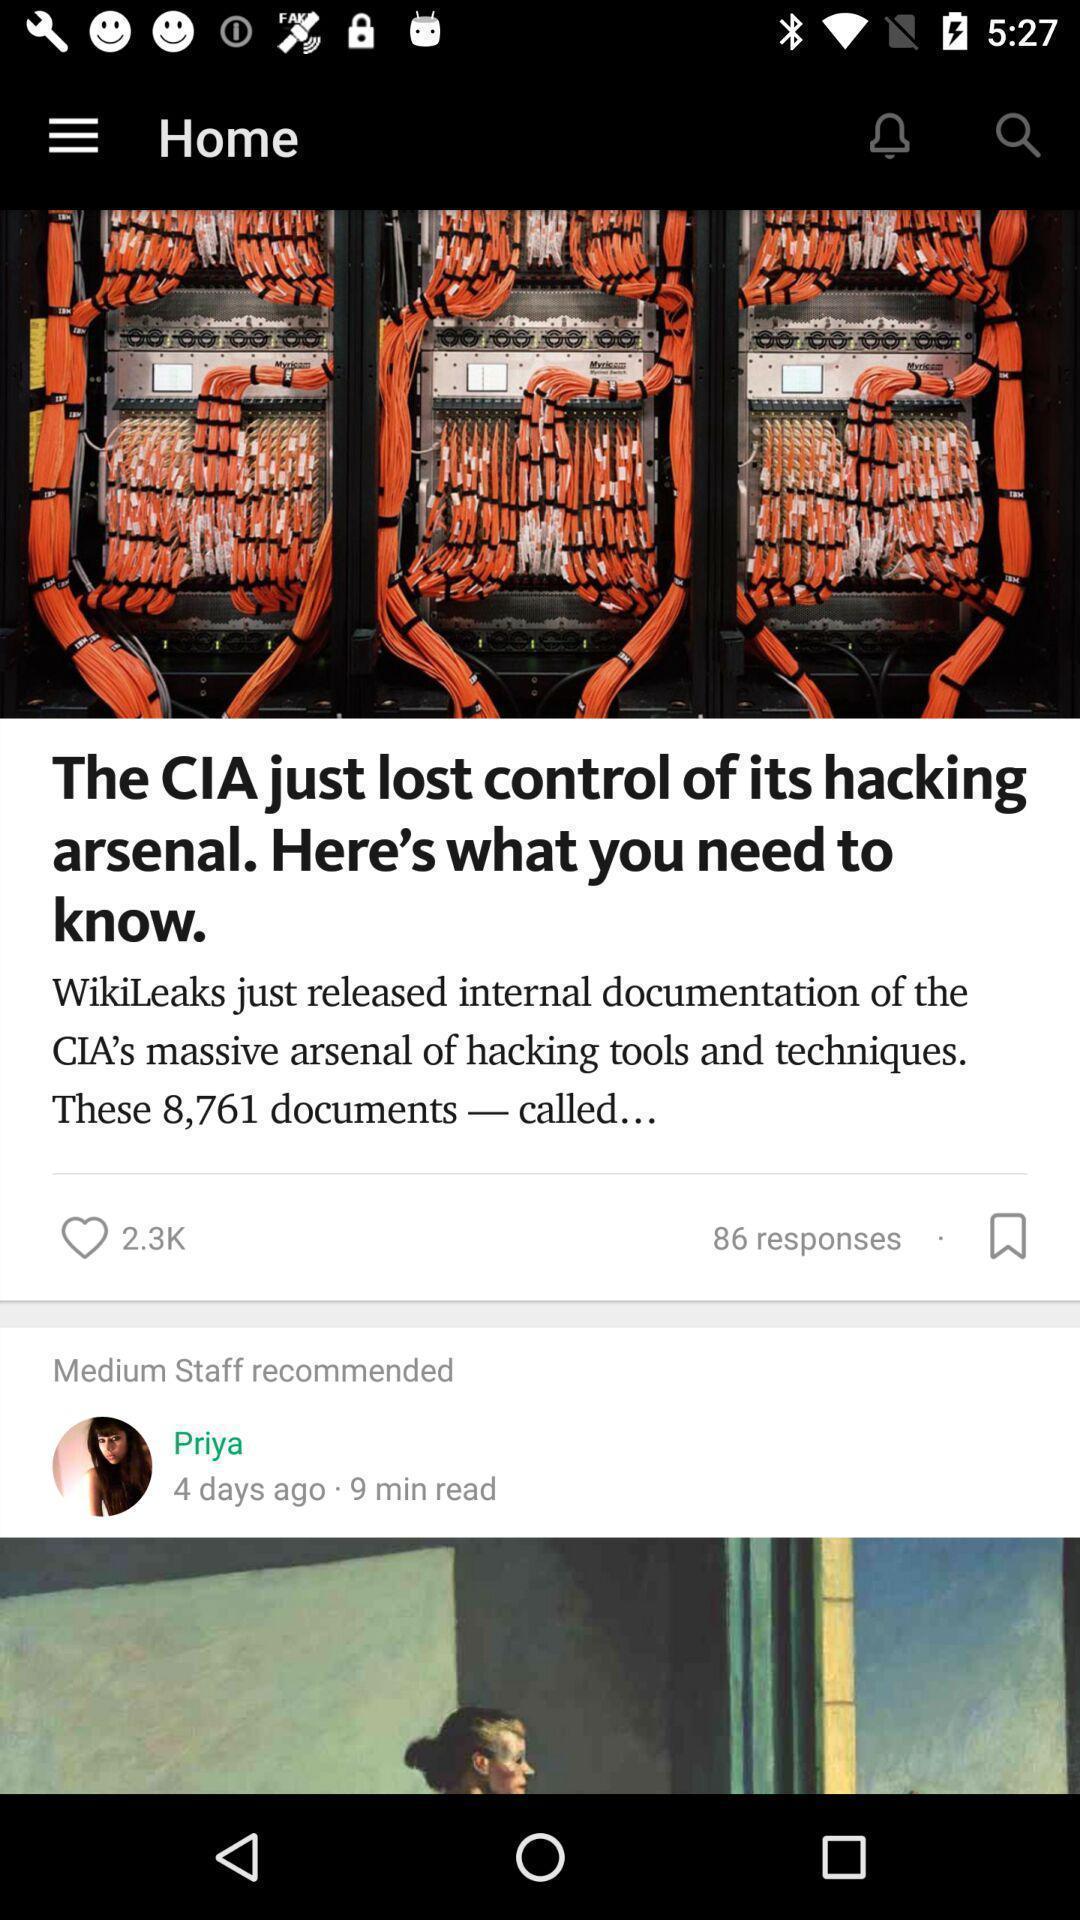What details can you identify in this image? Page showing different stories available. 